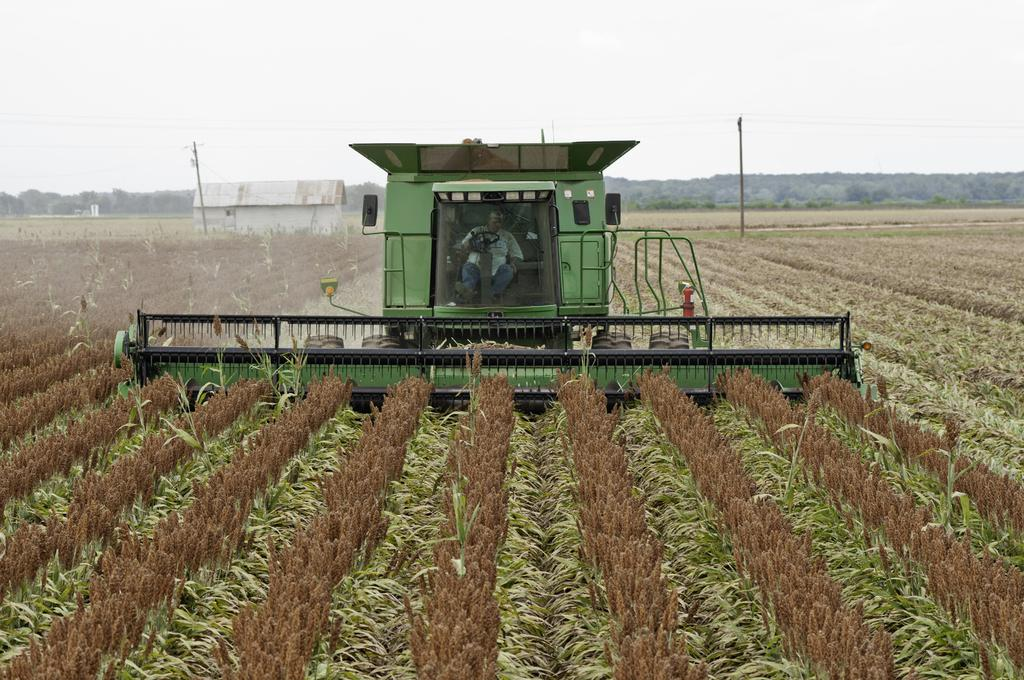What is the person in the image doing? There is a person riding a tractor in the image. Where is the tractor located? The tractor is in a field. What can be seen growing in the field? There are plants in the field. What other structures or objects can be seen in the background of the image? There are poles, a shelter, trees, and the sky visible in the background of the image. What type of skirt is the wren wearing in the image? There is no wren or skirt present in the image. How many buttons can be seen on the tractor in the image? The tractor does not have buttons; it is a mechanical vehicle. 